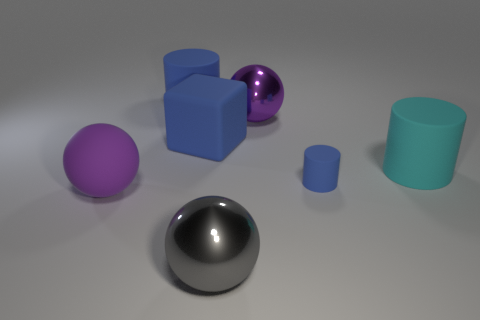What time of day does the lighting in the image suggest? The image seems to be artificially lit, rather than by natural light, as we can see shadows cast directly beneath the objects. It doesn't convey a particular time of day but rather looks like studio lighting used for highlighting the shapes and textures of the objects. 